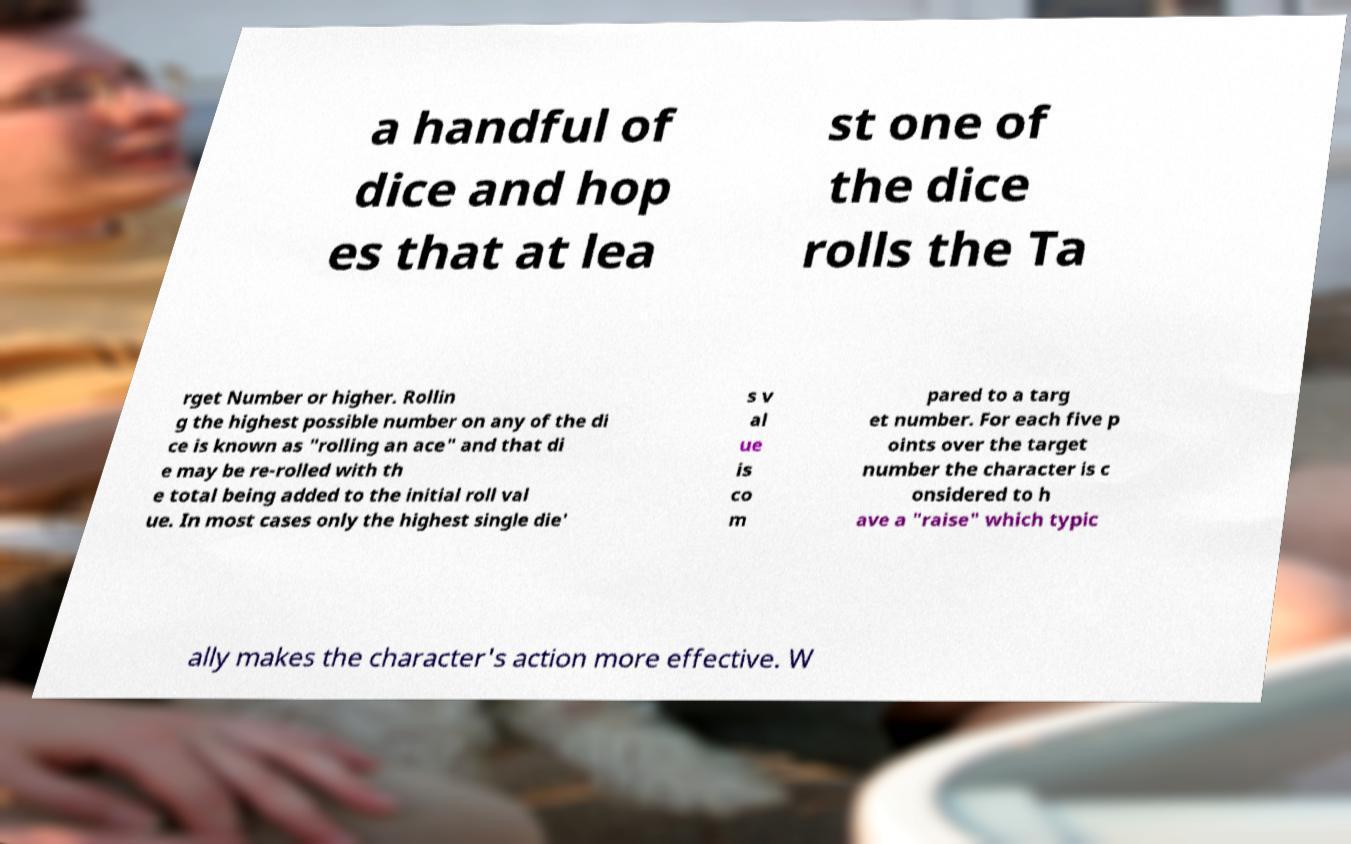There's text embedded in this image that I need extracted. Can you transcribe it verbatim? a handful of dice and hop es that at lea st one of the dice rolls the Ta rget Number or higher. Rollin g the highest possible number on any of the di ce is known as "rolling an ace" and that di e may be re-rolled with th e total being added to the initial roll val ue. In most cases only the highest single die' s v al ue is co m pared to a targ et number. For each five p oints over the target number the character is c onsidered to h ave a "raise" which typic ally makes the character's action more effective. W 